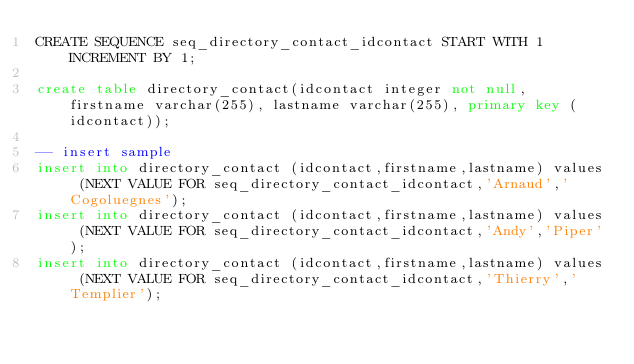<code> <loc_0><loc_0><loc_500><loc_500><_SQL_>CREATE SEQUENCE seq_directory_contact_idcontact START WITH 1 INCREMENT BY 1; 

create table directory_contact(idcontact integer not null, firstname varchar(255), lastname varchar(255), primary key (idcontact));

-- insert sample
insert into directory_contact (idcontact,firstname,lastname) values (NEXT VALUE FOR seq_directory_contact_idcontact,'Arnaud','Cogoluegnes');
insert into directory_contact (idcontact,firstname,lastname) values (NEXT VALUE FOR seq_directory_contact_idcontact,'Andy','Piper');
insert into directory_contact (idcontact,firstname,lastname) values (NEXT VALUE FOR seq_directory_contact_idcontact,'Thierry','Templier');</code> 